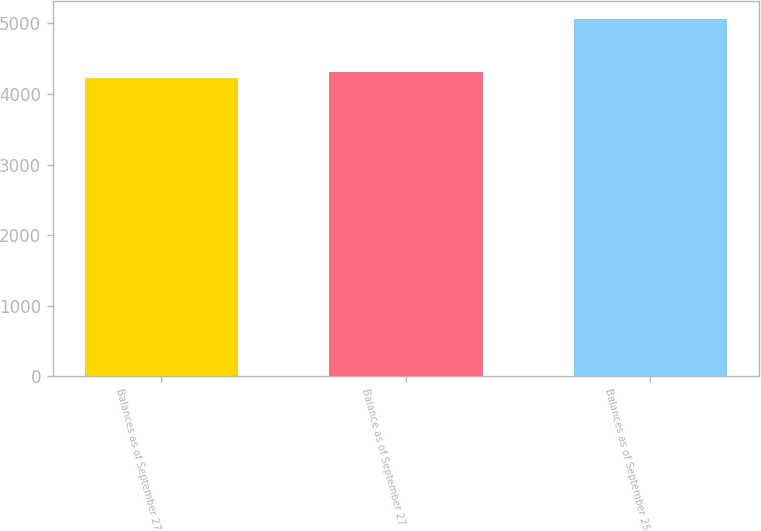Convert chart to OTSL. <chart><loc_0><loc_0><loc_500><loc_500><bar_chart><fcel>Balances as of September 27<fcel>Balance as of September 27<fcel>Balances as of September 25<nl><fcel>4223<fcel>4307<fcel>5063<nl></chart> 